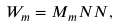Convert formula to latex. <formula><loc_0><loc_0><loc_500><loc_500>W _ { m } = M _ { m } N N ,</formula> 